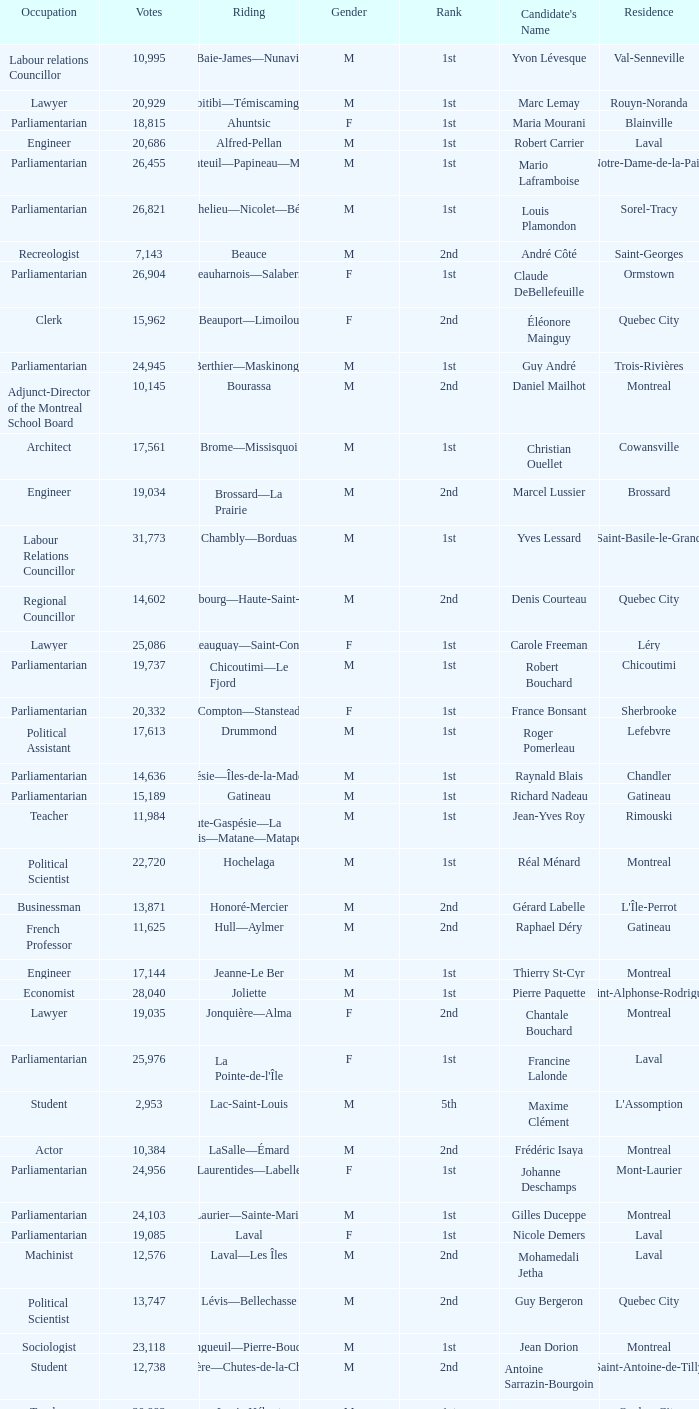What is the highest number of votes for the French Professor? 11625.0. 